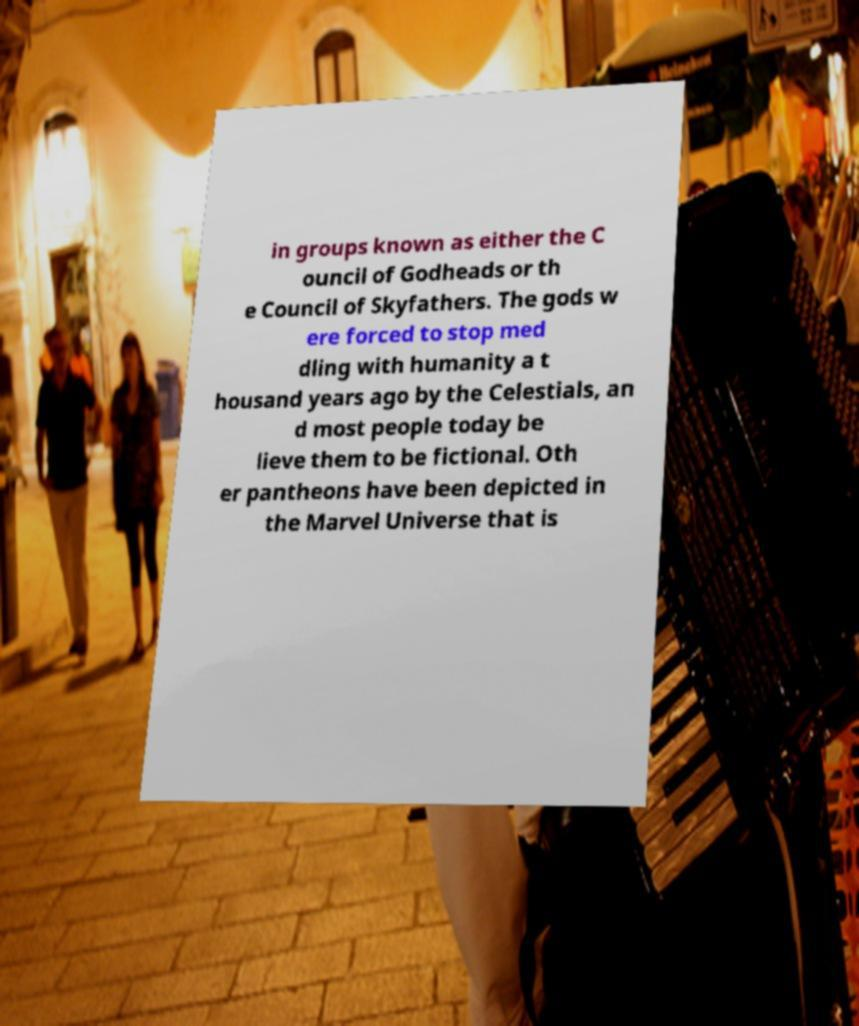There's text embedded in this image that I need extracted. Can you transcribe it verbatim? in groups known as either the C ouncil of Godheads or th e Council of Skyfathers. The gods w ere forced to stop med dling with humanity a t housand years ago by the Celestials, an d most people today be lieve them to be fictional. Oth er pantheons have been depicted in the Marvel Universe that is 